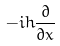Convert formula to latex. <formula><loc_0><loc_0><loc_500><loc_500>- i h \frac { \partial } { \partial x }</formula> 